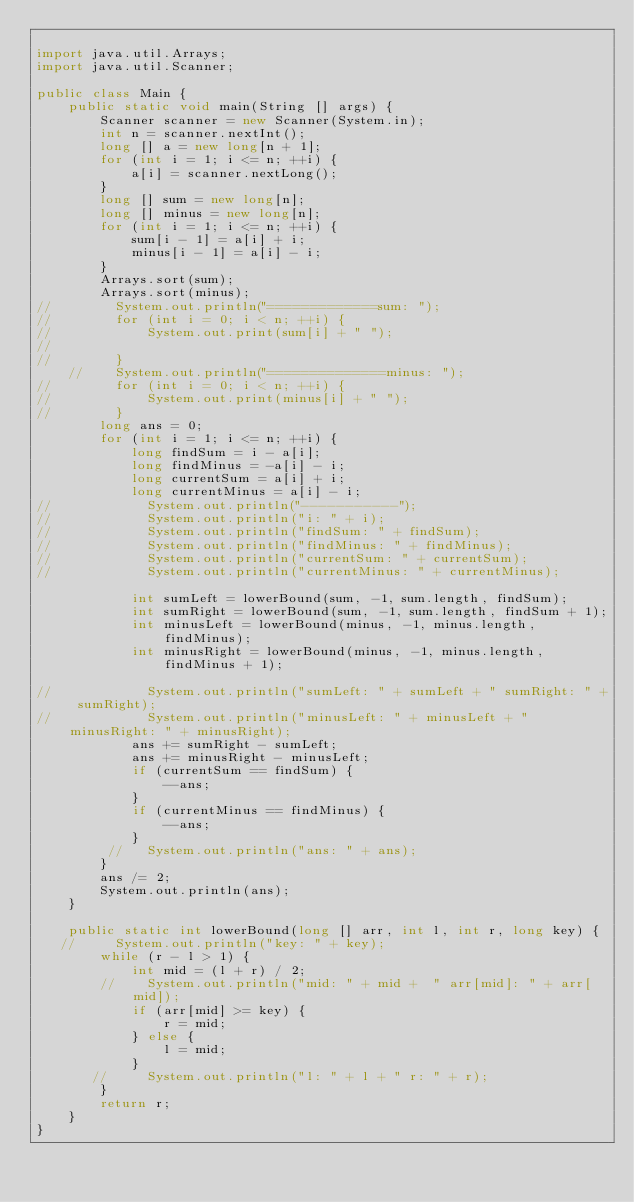<code> <loc_0><loc_0><loc_500><loc_500><_Java_>
import java.util.Arrays;
import java.util.Scanner;

public class Main {
    public static void main(String [] args) {
        Scanner scanner = new Scanner(System.in);
        int n = scanner.nextInt();
        long [] a = new long[n + 1];
        for (int i = 1; i <= n; ++i) {
            a[i] = scanner.nextLong();
        }
        long [] sum = new long[n];
        long [] minus = new long[n];
        for (int i = 1; i <= n; ++i) {
            sum[i - 1] = a[i] + i;
            minus[i - 1] = a[i] - i;
        }
        Arrays.sort(sum);
        Arrays.sort(minus);
//        System.out.println("=============sum: ");
//        for (int i = 0; i < n; ++i) {
//            System.out.print(sum[i] + " ");
//
//        }
    //    System.out.println("==============minus: ");
//        for (int i = 0; i < n; ++i) {
//            System.out.print(minus[i] + " ");
//        }
        long ans = 0;
        for (int i = 1; i <= n; ++i) {
            long findSum = i - a[i];
            long findMinus = -a[i] - i;
            long currentSum = a[i] + i;
            long currentMinus = a[i] - i;
//            System.out.println("-----------");
//            System.out.println("i: " + i);
//            System.out.println("findSum: " + findSum);
//            System.out.println("findMinus: " + findMinus);
//            System.out.println("currentSum: " + currentSum);
//            System.out.println("currentMinus: " + currentMinus);

            int sumLeft = lowerBound(sum, -1, sum.length, findSum);
            int sumRight = lowerBound(sum, -1, sum.length, findSum + 1);
            int minusLeft = lowerBound(minus, -1, minus.length, findMinus);
            int minusRight = lowerBound(minus, -1, minus.length, findMinus + 1);

//            System.out.println("sumLeft: " + sumLeft + " sumRight: " + sumRight);
//            System.out.println("minusLeft: " + minusLeft + " minusRight: " + minusRight);
            ans += sumRight - sumLeft;
            ans += minusRight - minusLeft;
            if (currentSum == findSum) {
                --ans;
            }
            if (currentMinus == findMinus) {
                --ans;
            }
         //   System.out.println("ans: " + ans);
        }
        ans /= 2;
        System.out.println(ans);
    }

    public static int lowerBound(long [] arr, int l, int r, long key) {
   //     System.out.println("key: " + key);
        while (r - l > 1) {
            int mid = (l + r) / 2;
        //    System.out.println("mid: " + mid +  " arr[mid]: " + arr[mid]);
            if (arr[mid] >= key) {
                r = mid;
            } else {
                l = mid;
            }
       //     System.out.println("l: " + l + " r: " + r);
        }
        return r;
    }
}
</code> 